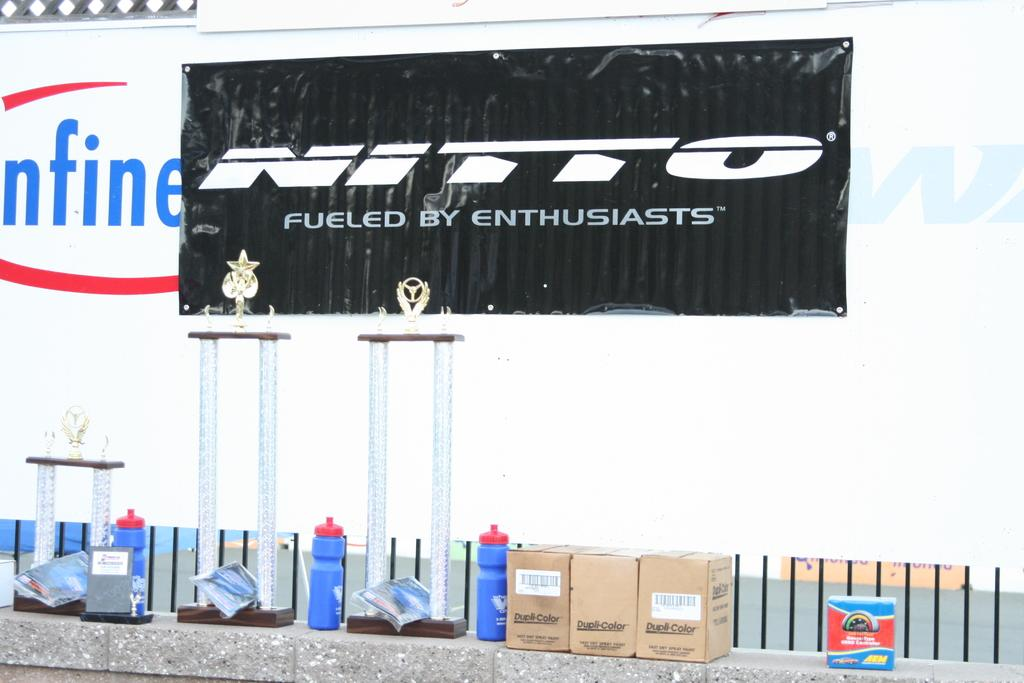<image>
Describe the image concisely. Blue water bottles on a brick wall in front of a sign that says Nitto Fueled By Enthusiasts. 